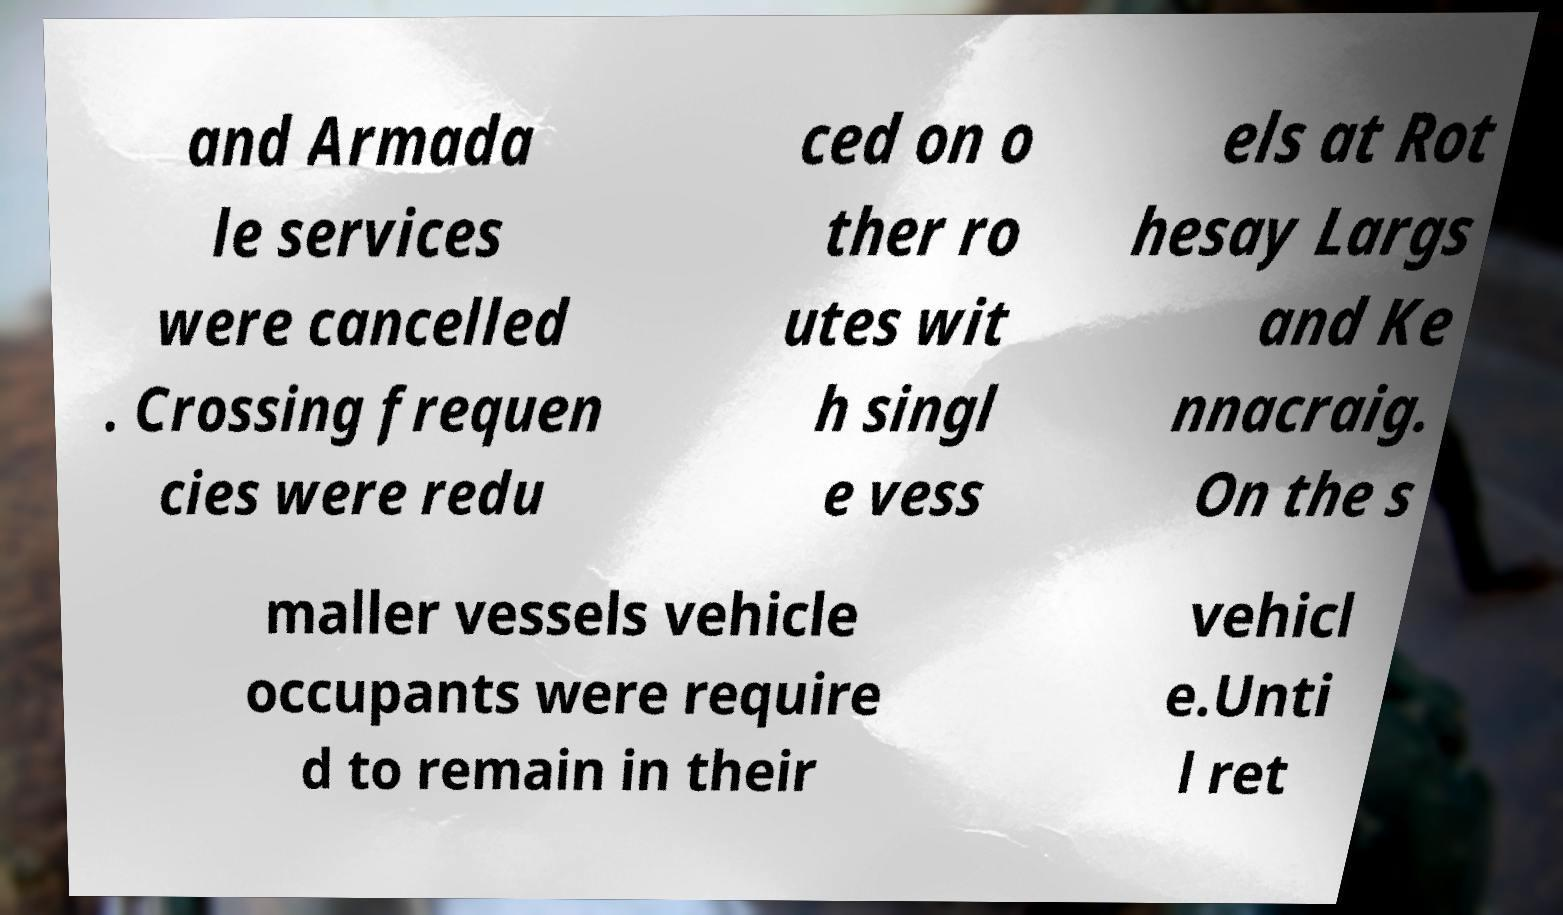Please identify and transcribe the text found in this image. and Armada le services were cancelled . Crossing frequen cies were redu ced on o ther ro utes wit h singl e vess els at Rot hesay Largs and Ke nnacraig. On the s maller vessels vehicle occupants were require d to remain in their vehicl e.Unti l ret 